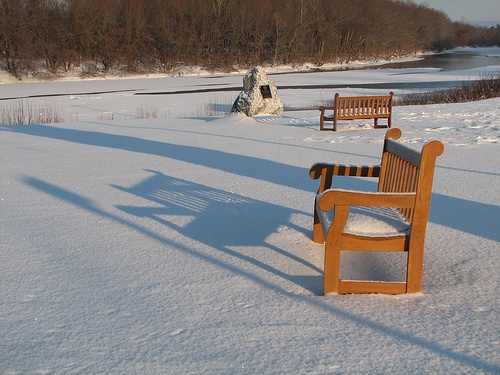Describe the objects in this image and their specific colors. I can see bench in black, brown, gray, and darkgray tones and bench in black, brown, maroon, and darkgray tones in this image. 